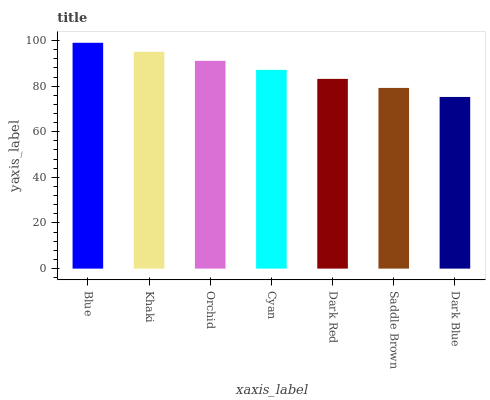Is Dark Blue the minimum?
Answer yes or no. Yes. Is Blue the maximum?
Answer yes or no. Yes. Is Khaki the minimum?
Answer yes or no. No. Is Khaki the maximum?
Answer yes or no. No. Is Blue greater than Khaki?
Answer yes or no. Yes. Is Khaki less than Blue?
Answer yes or no. Yes. Is Khaki greater than Blue?
Answer yes or no. No. Is Blue less than Khaki?
Answer yes or no. No. Is Cyan the high median?
Answer yes or no. Yes. Is Cyan the low median?
Answer yes or no. Yes. Is Khaki the high median?
Answer yes or no. No. Is Dark Blue the low median?
Answer yes or no. No. 